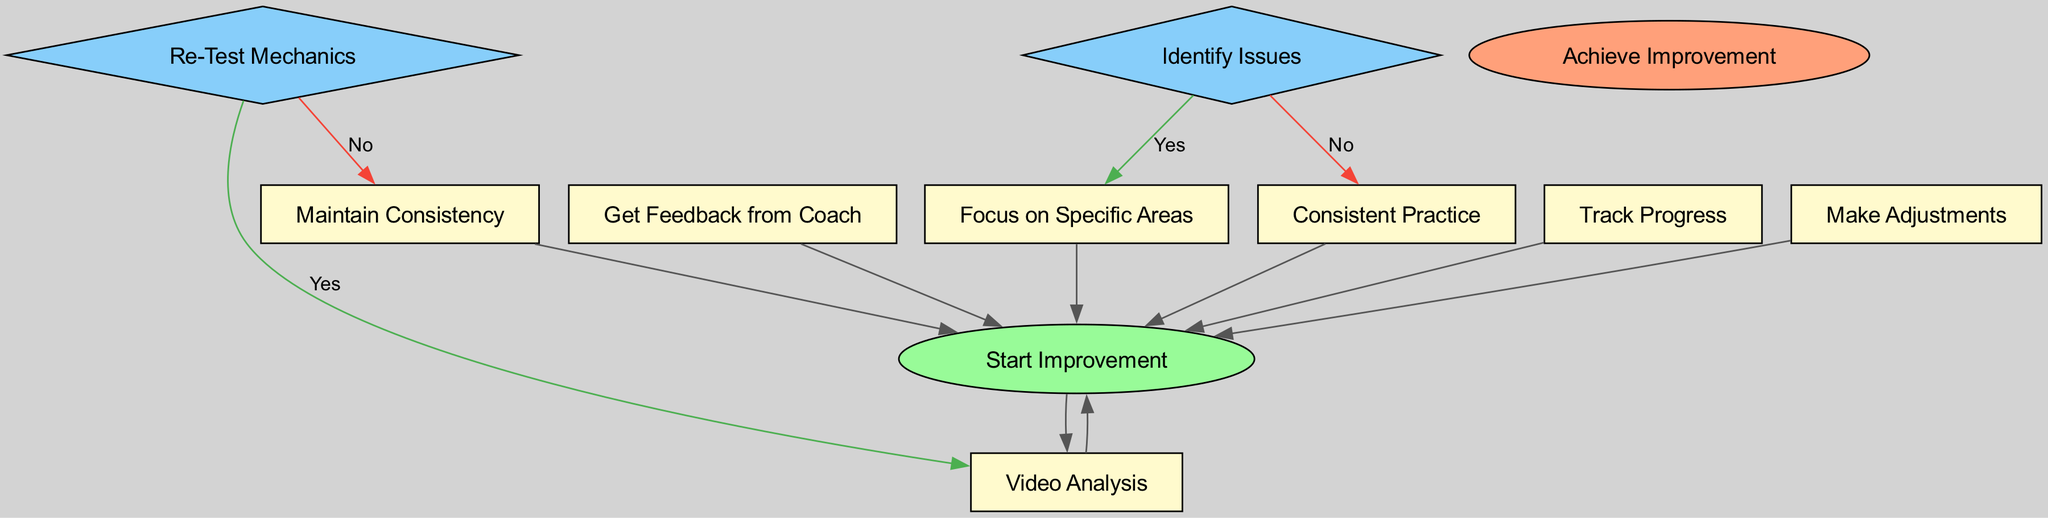What is the first step in the improvement process? The diagram starts with the node labeled "Start Improvement," indicating that this is the first step in the process of improving free-throw mechanics.
Answer: Start Improvement How many decision nodes are there in the diagram? The diagram has two decision nodes: "Identify Issues" and "Re-Test Mechanics." Therefore, there are a total of two decision nodes.
Answer: 2 What happens after "Get Feedback from Coach"? After "Get Feedback from Coach," the next step is to "Identify Issues," which is a decision node that leads to either focusing on specific areas or consistent practice.
Answer: Identify Issues If issues are identified, what is the next step? If issues are identified (the 'yes' option from "Identify Issues"), the next step is "Focus on Specific Areas," where the individual works on identified weaknesses in their free-throw technique.
Answer: Focus on Specific Areas What is the final step in the improvement process? The final step in the diagram is labeled "Achieve Improvement," indicating the completion of the process after reaching the desired level of improvement in free-throw mechanics.
Answer: Achieve Improvement What action follows "Consistent Practice"? The action following "Consistent Practice" is to "Track Progress." This step involves logging the success rate over time to monitor improvement.
Answer: Track Progress What do you do if no issues are identified in your mechanics? If no issues are identified (the 'no' option from "Identify Issues"), the next step is "Consistent Practice," which suggests continuing practice without focusing on specific areas.
Answer: Consistent Practice How is progress tracked in the diagram? Progress is tracked through the step labeled "Track Progress," which involves maintaining a log of free-throw success rates over time.
Answer: Track Progress What is the relationship between "Re-Test Mechanics" and "Video Analysis"? If further improvements are needed (the 'yes' from "Re-Test Mechanics"), the process loops back to "Video Analysis" for further analysis and feedback on mechanics.
Answer: Video Analysis 